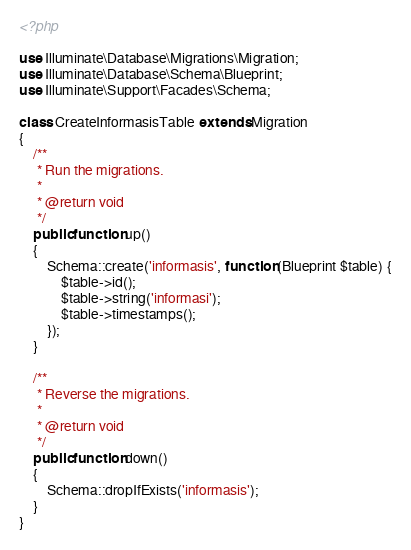<code> <loc_0><loc_0><loc_500><loc_500><_PHP_><?php

use Illuminate\Database\Migrations\Migration;
use Illuminate\Database\Schema\Blueprint;
use Illuminate\Support\Facades\Schema;

class CreateInformasisTable extends Migration
{
    /**
     * Run the migrations.
     *
     * @return void
     */
    public function up()
    {
        Schema::create('informasis', function (Blueprint $table) {
            $table->id();
            $table->string('informasi');
            $table->timestamps();
        });
    }

    /**
     * Reverse the migrations.
     *
     * @return void
     */
    public function down()
    {
        Schema::dropIfExists('informasis');
    }
}
</code> 